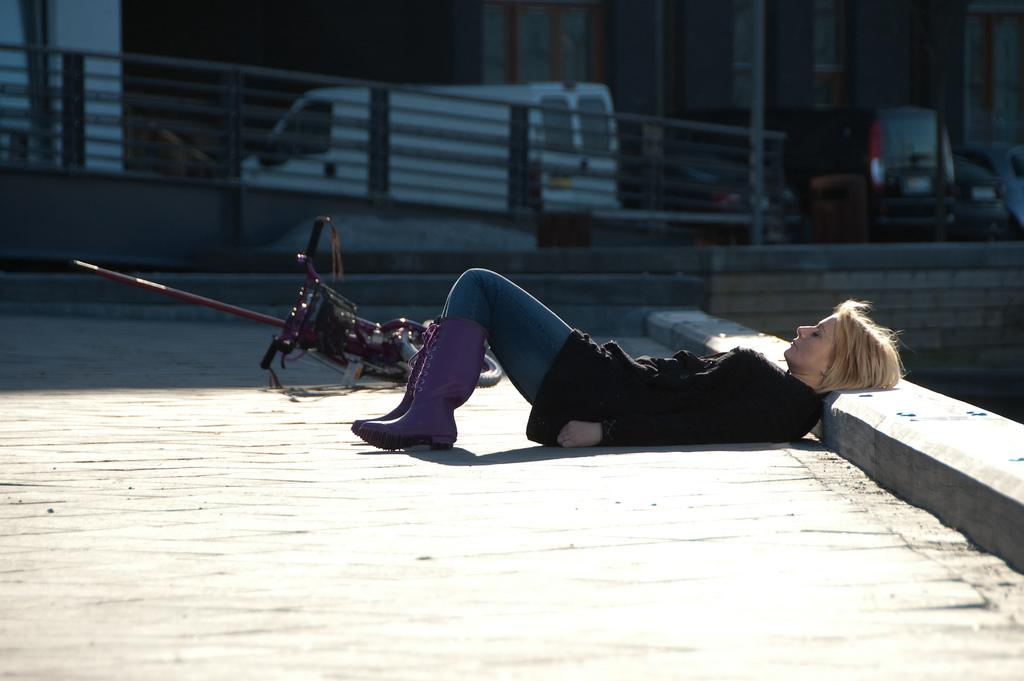What is the woman doing in the image? The woman is laying on the ground in the image. What else can be seen in the image besides the woman? There is a bicycle in the image. What type of object is the bicycle? The bicycle is likely a vehicle. Are there any other structures or objects in the image that are less certain? There may be iron grilles in the image, but this is less certain due to the ambiguity in the transcript. How many boats are visible in the image? There are no boats visible in the image. What mathematical operation is being performed in the image? There is no mathematical operation being performed in the image. 